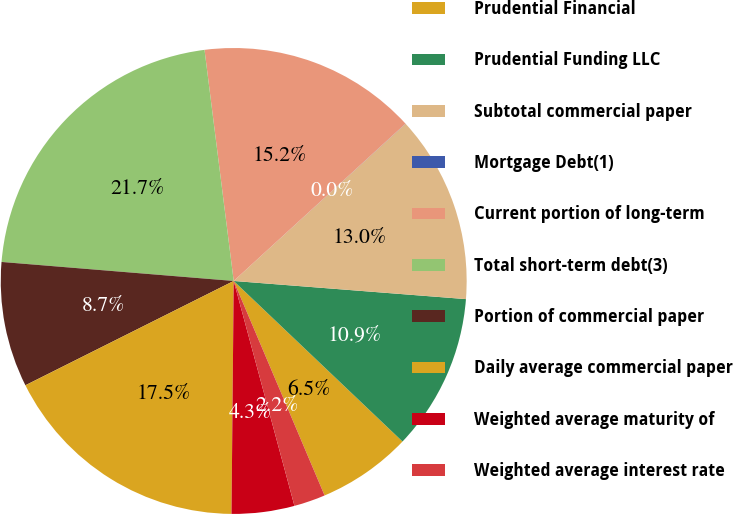<chart> <loc_0><loc_0><loc_500><loc_500><pie_chart><fcel>Prudential Financial<fcel>Prudential Funding LLC<fcel>Subtotal commercial paper<fcel>Mortgage Debt(1)<fcel>Current portion of long-term<fcel>Total short-term debt(3)<fcel>Portion of commercial paper<fcel>Daily average commercial paper<fcel>Weighted average maturity of<fcel>Weighted average interest rate<nl><fcel>6.52%<fcel>10.86%<fcel>13.03%<fcel>0.01%<fcel>15.2%<fcel>21.7%<fcel>8.69%<fcel>17.46%<fcel>4.35%<fcel>2.18%<nl></chart> 